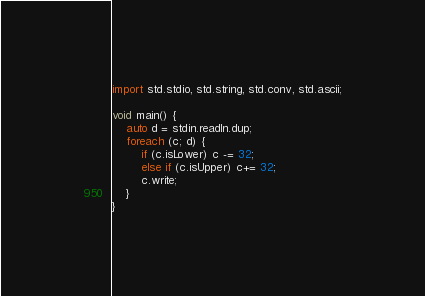<code> <loc_0><loc_0><loc_500><loc_500><_D_>import std.stdio, std.string, std.conv, std.ascii;

void main() {	
	auto d = stdin.readln.dup;
	foreach (c; d) {
		if (c.isLower) c -= 32;
		else if (c.isUpper) c+= 32;
		c.write;
	}
}</code> 